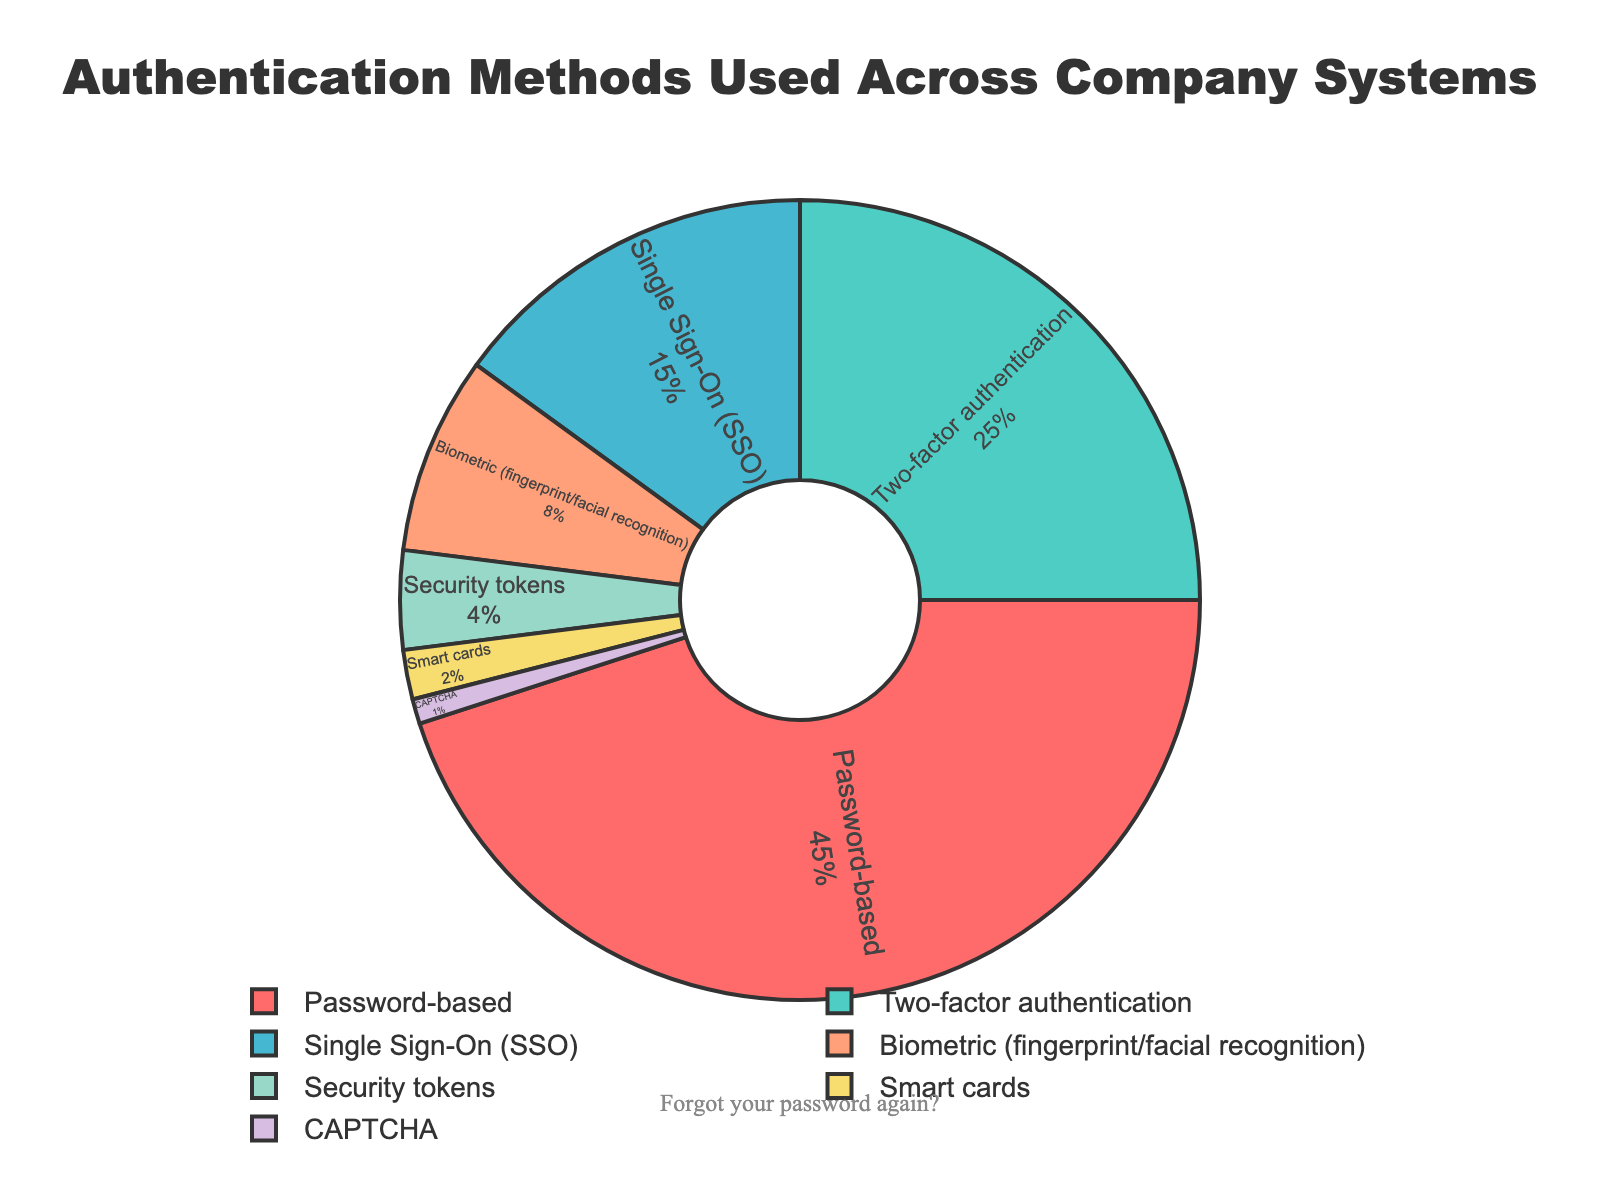What's the most commonly used authentication method? The chart shows that Password-based authentication occupies the largest portion with 45%.
Answer: Password-based What's the least commonly used authentication method? The chart shows that CAPTCHA occupies the smallest portion with 1%.
Answer: CAPTCHA What is the total percentage of methods that require more than one factor for authentication (Two-factor authentication + Security tokens + Smart cards)? Add the percentages of Two-factor authentication (25%), Security tokens (4%), and Smart cards (2%): 25 + 4 + 2 = 31%.
Answer: 31% Which method is more prevalent: Single Sign-On (SSO) or Biometric authentication? Single Sign-On (SSO) has 15% while Biometric authentication has 8%. Therefore, Single Sign-On (SSO) is more prevalent.
Answer: Single Sign-On (SSO) How much more common is Two-factor authentication compared to Security tokens? Two-factor authentication is 25% and Security tokens are 4%. Subtracting 4 from 25 gives 21%.
Answer: 21% What percentage of methods use physical devices (Security tokens + Smart cards)? Add the percentages of Security tokens (4%) and Smart cards (2%): 4 + 2 = 6%.
Answer: 6% Which color represents Biometric (fingerprint/facial recognition) authentication? The chart shows Biometric authentication in the orange-colored section.
Answer: Orange Are there more methods under 10% or over 10%? Methods under 10%: Biometric (8%), Security tokens (4%), Smart cards (2%), CAPTCHA (1%)—total 4 methods. Methods over 10%: Password-based (45%), Two-factor (25%), SSO (15%)—total 3 methods. Therefore, there are more methods under 10%.
Answer: Under 10% What is the combined percentage of Single Sign-On (SSO) and Biometric authentication? Add the percentages of Single Sign-On (15%) and Biometric (8%): 15 + 8 = 23%.
Answer: 23% Which method uses the green color on the pie chart? The chart shows that Two-factor authentication is represented by the green-colored section.
Answer: Two-factor authentication 